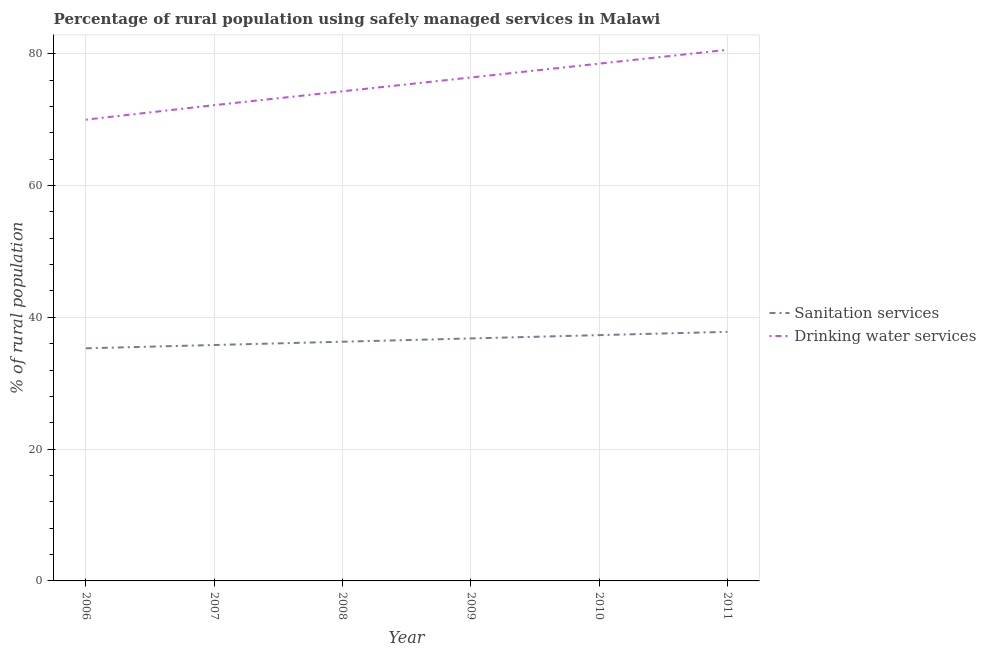How many different coloured lines are there?
Ensure brevity in your answer.  2. Is the number of lines equal to the number of legend labels?
Your answer should be compact. Yes. What is the percentage of rural population who used sanitation services in 2011?
Provide a short and direct response. 37.8. Across all years, what is the maximum percentage of rural population who used sanitation services?
Ensure brevity in your answer.  37.8. In which year was the percentage of rural population who used sanitation services maximum?
Give a very brief answer. 2011. In which year was the percentage of rural population who used drinking water services minimum?
Your response must be concise. 2006. What is the total percentage of rural population who used sanitation services in the graph?
Make the answer very short. 219.3. What is the difference between the percentage of rural population who used drinking water services in 2008 and that in 2011?
Ensure brevity in your answer.  -6.3. What is the difference between the percentage of rural population who used sanitation services in 2007 and the percentage of rural population who used drinking water services in 2006?
Provide a short and direct response. -34.2. What is the average percentage of rural population who used sanitation services per year?
Provide a short and direct response. 36.55. In the year 2008, what is the difference between the percentage of rural population who used sanitation services and percentage of rural population who used drinking water services?
Your response must be concise. -38. In how many years, is the percentage of rural population who used drinking water services greater than 12 %?
Your answer should be compact. 6. What is the ratio of the percentage of rural population who used drinking water services in 2006 to that in 2007?
Offer a very short reply. 0.97. Is the difference between the percentage of rural population who used drinking water services in 2010 and 2011 greater than the difference between the percentage of rural population who used sanitation services in 2010 and 2011?
Ensure brevity in your answer.  No. What is the difference between the highest and the second highest percentage of rural population who used drinking water services?
Your answer should be very brief. 2.1. What is the difference between the highest and the lowest percentage of rural population who used sanitation services?
Ensure brevity in your answer.  2.5. Is the percentage of rural population who used sanitation services strictly less than the percentage of rural population who used drinking water services over the years?
Provide a short and direct response. Yes. How many lines are there?
Offer a very short reply. 2. What is the difference between two consecutive major ticks on the Y-axis?
Keep it short and to the point. 20. Are the values on the major ticks of Y-axis written in scientific E-notation?
Ensure brevity in your answer.  No. Does the graph contain grids?
Your response must be concise. Yes. Where does the legend appear in the graph?
Offer a terse response. Center right. How many legend labels are there?
Provide a succinct answer. 2. How are the legend labels stacked?
Your answer should be very brief. Vertical. What is the title of the graph?
Ensure brevity in your answer.  Percentage of rural population using safely managed services in Malawi. Does "Taxes on exports" appear as one of the legend labels in the graph?
Your answer should be compact. No. What is the label or title of the Y-axis?
Keep it short and to the point. % of rural population. What is the % of rural population of Sanitation services in 2006?
Give a very brief answer. 35.3. What is the % of rural population in Sanitation services in 2007?
Provide a short and direct response. 35.8. What is the % of rural population of Drinking water services in 2007?
Give a very brief answer. 72.2. What is the % of rural population of Sanitation services in 2008?
Give a very brief answer. 36.3. What is the % of rural population in Drinking water services in 2008?
Offer a terse response. 74.3. What is the % of rural population in Sanitation services in 2009?
Give a very brief answer. 36.8. What is the % of rural population of Drinking water services in 2009?
Offer a terse response. 76.4. What is the % of rural population in Sanitation services in 2010?
Ensure brevity in your answer.  37.3. What is the % of rural population of Drinking water services in 2010?
Ensure brevity in your answer.  78.5. What is the % of rural population of Sanitation services in 2011?
Keep it short and to the point. 37.8. What is the % of rural population in Drinking water services in 2011?
Give a very brief answer. 80.6. Across all years, what is the maximum % of rural population of Sanitation services?
Your answer should be compact. 37.8. Across all years, what is the maximum % of rural population of Drinking water services?
Your answer should be very brief. 80.6. Across all years, what is the minimum % of rural population of Sanitation services?
Ensure brevity in your answer.  35.3. Across all years, what is the minimum % of rural population in Drinking water services?
Offer a terse response. 70. What is the total % of rural population of Sanitation services in the graph?
Your answer should be compact. 219.3. What is the total % of rural population of Drinking water services in the graph?
Provide a short and direct response. 452. What is the difference between the % of rural population in Sanitation services in 2006 and that in 2008?
Your response must be concise. -1. What is the difference between the % of rural population of Sanitation services in 2006 and that in 2009?
Give a very brief answer. -1.5. What is the difference between the % of rural population of Drinking water services in 2006 and that in 2010?
Provide a short and direct response. -8.5. What is the difference between the % of rural population of Sanitation services in 2007 and that in 2009?
Your answer should be very brief. -1. What is the difference between the % of rural population in Drinking water services in 2007 and that in 2009?
Make the answer very short. -4.2. What is the difference between the % of rural population in Sanitation services in 2007 and that in 2011?
Provide a succinct answer. -2. What is the difference between the % of rural population in Drinking water services in 2007 and that in 2011?
Your response must be concise. -8.4. What is the difference between the % of rural population in Sanitation services in 2008 and that in 2010?
Give a very brief answer. -1. What is the difference between the % of rural population of Drinking water services in 2008 and that in 2010?
Offer a very short reply. -4.2. What is the difference between the % of rural population in Sanitation services in 2008 and that in 2011?
Your answer should be very brief. -1.5. What is the difference between the % of rural population in Drinking water services in 2008 and that in 2011?
Offer a terse response. -6.3. What is the difference between the % of rural population in Sanitation services in 2009 and that in 2010?
Your response must be concise. -0.5. What is the difference between the % of rural population in Drinking water services in 2009 and that in 2010?
Provide a succinct answer. -2.1. What is the difference between the % of rural population of Sanitation services in 2009 and that in 2011?
Offer a very short reply. -1. What is the difference between the % of rural population in Drinking water services in 2009 and that in 2011?
Make the answer very short. -4.2. What is the difference between the % of rural population in Drinking water services in 2010 and that in 2011?
Provide a succinct answer. -2.1. What is the difference between the % of rural population of Sanitation services in 2006 and the % of rural population of Drinking water services in 2007?
Keep it short and to the point. -36.9. What is the difference between the % of rural population of Sanitation services in 2006 and the % of rural population of Drinking water services in 2008?
Your answer should be compact. -39. What is the difference between the % of rural population of Sanitation services in 2006 and the % of rural population of Drinking water services in 2009?
Keep it short and to the point. -41.1. What is the difference between the % of rural population of Sanitation services in 2006 and the % of rural population of Drinking water services in 2010?
Provide a short and direct response. -43.2. What is the difference between the % of rural population of Sanitation services in 2006 and the % of rural population of Drinking water services in 2011?
Make the answer very short. -45.3. What is the difference between the % of rural population of Sanitation services in 2007 and the % of rural population of Drinking water services in 2008?
Your response must be concise. -38.5. What is the difference between the % of rural population of Sanitation services in 2007 and the % of rural population of Drinking water services in 2009?
Give a very brief answer. -40.6. What is the difference between the % of rural population in Sanitation services in 2007 and the % of rural population in Drinking water services in 2010?
Offer a terse response. -42.7. What is the difference between the % of rural population of Sanitation services in 2007 and the % of rural population of Drinking water services in 2011?
Make the answer very short. -44.8. What is the difference between the % of rural population of Sanitation services in 2008 and the % of rural population of Drinking water services in 2009?
Ensure brevity in your answer.  -40.1. What is the difference between the % of rural population in Sanitation services in 2008 and the % of rural population in Drinking water services in 2010?
Ensure brevity in your answer.  -42.2. What is the difference between the % of rural population of Sanitation services in 2008 and the % of rural population of Drinking water services in 2011?
Give a very brief answer. -44.3. What is the difference between the % of rural population of Sanitation services in 2009 and the % of rural population of Drinking water services in 2010?
Give a very brief answer. -41.7. What is the difference between the % of rural population in Sanitation services in 2009 and the % of rural population in Drinking water services in 2011?
Offer a terse response. -43.8. What is the difference between the % of rural population in Sanitation services in 2010 and the % of rural population in Drinking water services in 2011?
Your answer should be compact. -43.3. What is the average % of rural population in Sanitation services per year?
Offer a terse response. 36.55. What is the average % of rural population in Drinking water services per year?
Keep it short and to the point. 75.33. In the year 2006, what is the difference between the % of rural population of Sanitation services and % of rural population of Drinking water services?
Your response must be concise. -34.7. In the year 2007, what is the difference between the % of rural population of Sanitation services and % of rural population of Drinking water services?
Ensure brevity in your answer.  -36.4. In the year 2008, what is the difference between the % of rural population of Sanitation services and % of rural population of Drinking water services?
Provide a short and direct response. -38. In the year 2009, what is the difference between the % of rural population in Sanitation services and % of rural population in Drinking water services?
Ensure brevity in your answer.  -39.6. In the year 2010, what is the difference between the % of rural population of Sanitation services and % of rural population of Drinking water services?
Offer a terse response. -41.2. In the year 2011, what is the difference between the % of rural population in Sanitation services and % of rural population in Drinking water services?
Your response must be concise. -42.8. What is the ratio of the % of rural population of Sanitation services in 2006 to that in 2007?
Offer a very short reply. 0.99. What is the ratio of the % of rural population of Drinking water services in 2006 to that in 2007?
Offer a terse response. 0.97. What is the ratio of the % of rural population of Sanitation services in 2006 to that in 2008?
Ensure brevity in your answer.  0.97. What is the ratio of the % of rural population in Drinking water services in 2006 to that in 2008?
Offer a very short reply. 0.94. What is the ratio of the % of rural population in Sanitation services in 2006 to that in 2009?
Your response must be concise. 0.96. What is the ratio of the % of rural population of Drinking water services in 2006 to that in 2009?
Your response must be concise. 0.92. What is the ratio of the % of rural population of Sanitation services in 2006 to that in 2010?
Offer a terse response. 0.95. What is the ratio of the % of rural population of Drinking water services in 2006 to that in 2010?
Your response must be concise. 0.89. What is the ratio of the % of rural population of Sanitation services in 2006 to that in 2011?
Ensure brevity in your answer.  0.93. What is the ratio of the % of rural population in Drinking water services in 2006 to that in 2011?
Keep it short and to the point. 0.87. What is the ratio of the % of rural population of Sanitation services in 2007 to that in 2008?
Give a very brief answer. 0.99. What is the ratio of the % of rural population of Drinking water services in 2007 to that in 2008?
Provide a short and direct response. 0.97. What is the ratio of the % of rural population in Sanitation services in 2007 to that in 2009?
Offer a very short reply. 0.97. What is the ratio of the % of rural population in Drinking water services in 2007 to that in 2009?
Provide a short and direct response. 0.94. What is the ratio of the % of rural population in Sanitation services in 2007 to that in 2010?
Provide a succinct answer. 0.96. What is the ratio of the % of rural population in Drinking water services in 2007 to that in 2010?
Provide a succinct answer. 0.92. What is the ratio of the % of rural population of Sanitation services in 2007 to that in 2011?
Provide a short and direct response. 0.95. What is the ratio of the % of rural population of Drinking water services in 2007 to that in 2011?
Give a very brief answer. 0.9. What is the ratio of the % of rural population of Sanitation services in 2008 to that in 2009?
Provide a short and direct response. 0.99. What is the ratio of the % of rural population in Drinking water services in 2008 to that in 2009?
Offer a very short reply. 0.97. What is the ratio of the % of rural population of Sanitation services in 2008 to that in 2010?
Offer a very short reply. 0.97. What is the ratio of the % of rural population of Drinking water services in 2008 to that in 2010?
Provide a succinct answer. 0.95. What is the ratio of the % of rural population of Sanitation services in 2008 to that in 2011?
Provide a short and direct response. 0.96. What is the ratio of the % of rural population in Drinking water services in 2008 to that in 2011?
Your answer should be very brief. 0.92. What is the ratio of the % of rural population in Sanitation services in 2009 to that in 2010?
Provide a short and direct response. 0.99. What is the ratio of the % of rural population in Drinking water services in 2009 to that in 2010?
Offer a very short reply. 0.97. What is the ratio of the % of rural population of Sanitation services in 2009 to that in 2011?
Provide a succinct answer. 0.97. What is the ratio of the % of rural population in Drinking water services in 2009 to that in 2011?
Provide a short and direct response. 0.95. What is the ratio of the % of rural population of Drinking water services in 2010 to that in 2011?
Offer a terse response. 0.97. What is the difference between the highest and the second highest % of rural population in Sanitation services?
Keep it short and to the point. 0.5. What is the difference between the highest and the lowest % of rural population of Sanitation services?
Give a very brief answer. 2.5. What is the difference between the highest and the lowest % of rural population in Drinking water services?
Your answer should be very brief. 10.6. 